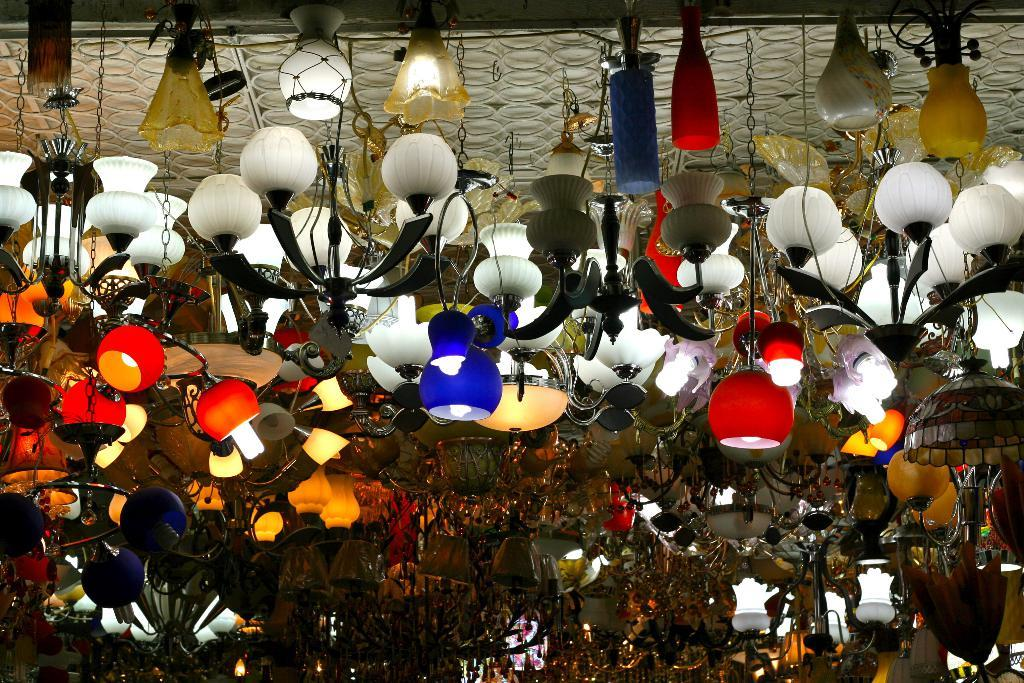What type of lighting fixtures are present in the image? There are many lamps and lanterns in the image. Where are the lamps and lanterns located? The lamps and lanterns are on a rooftop. What thoughts are the lamps and lanterns expressing in the image? Lamps and lanterns do not have the ability to express thoughts, as they are inanimate objects. 